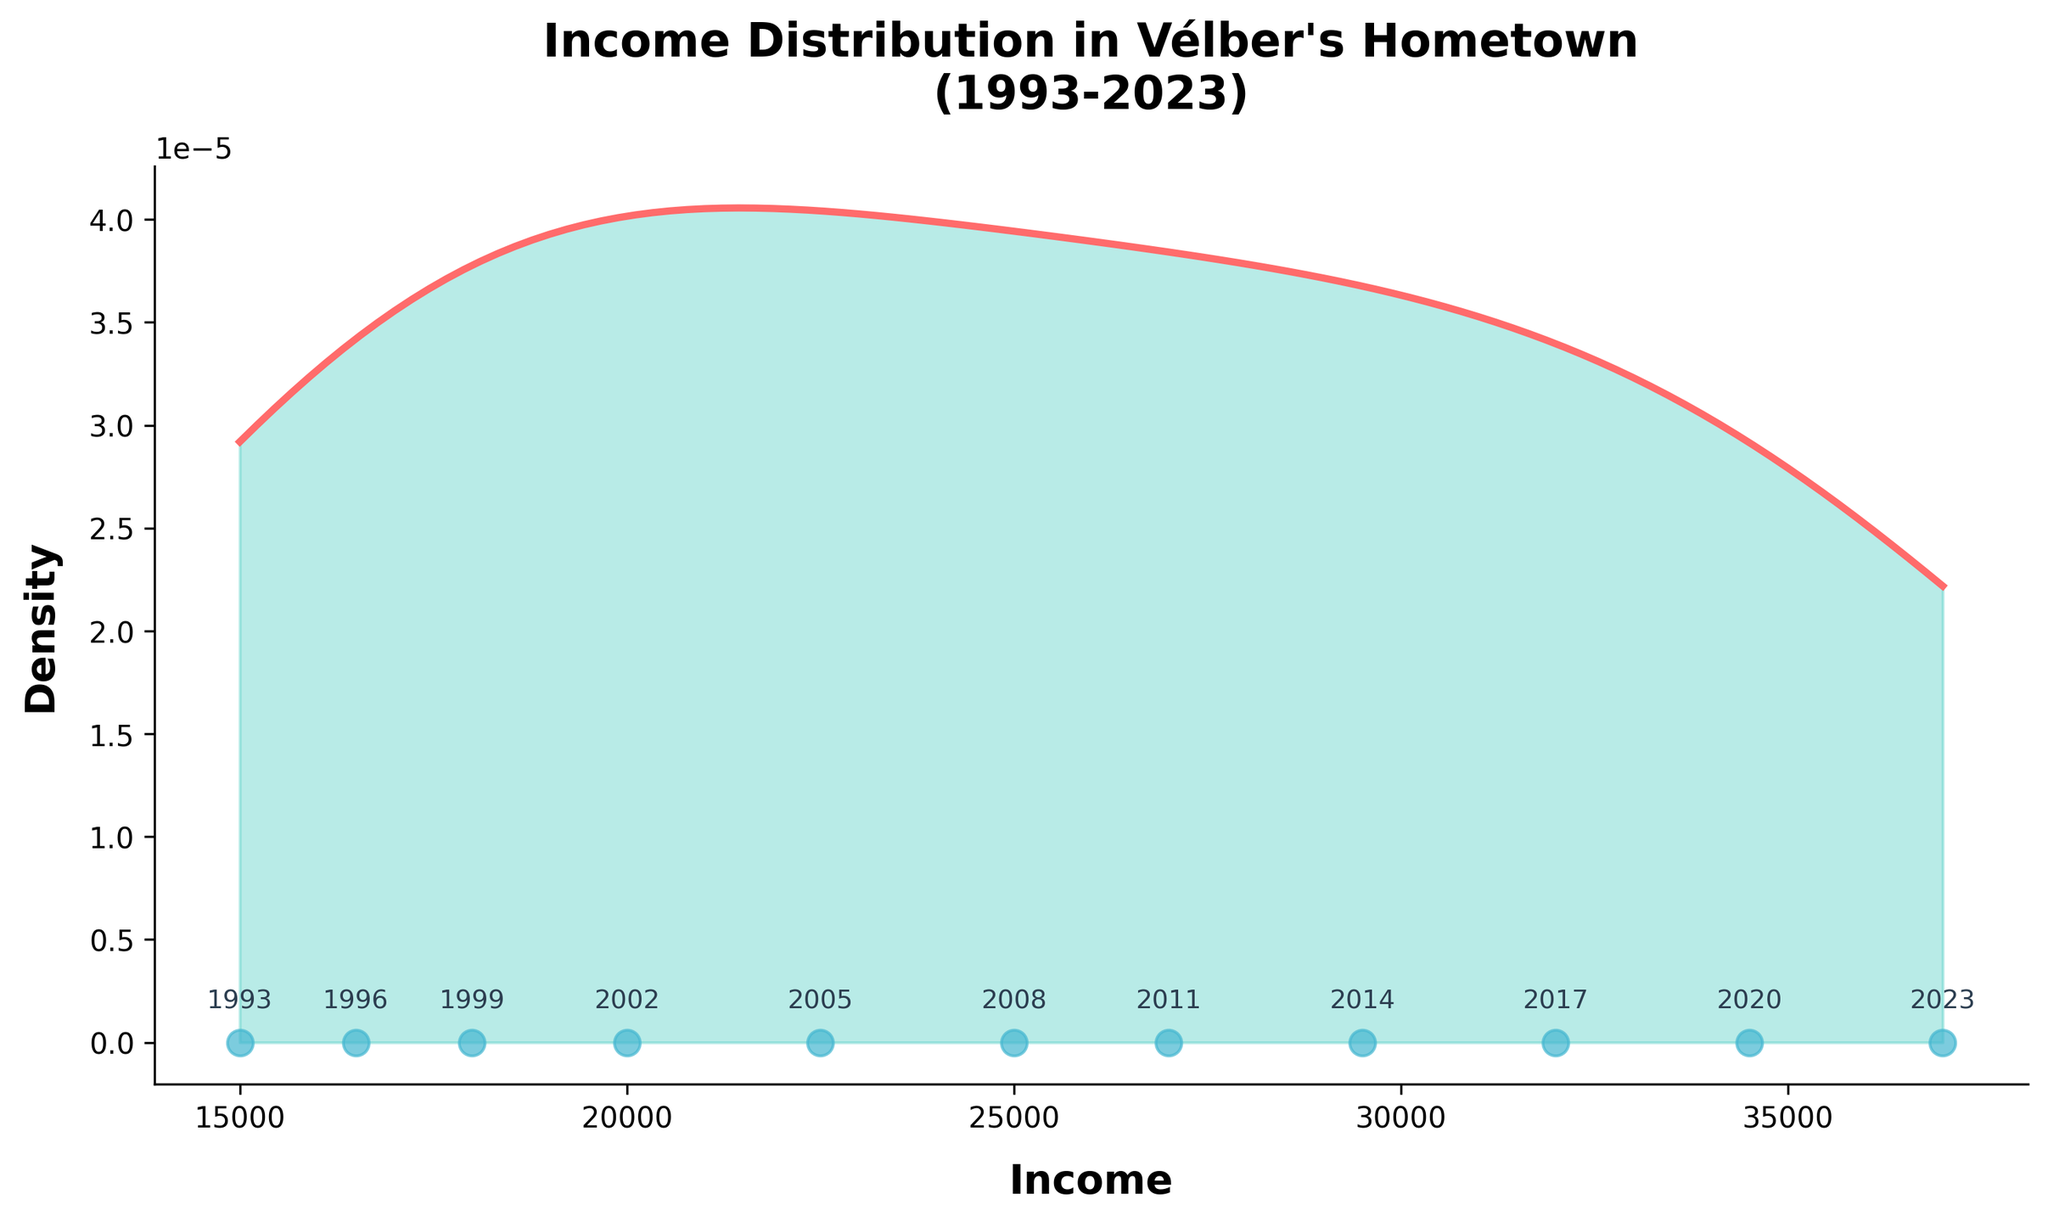what is the title of the plot? The title is located at the top of the figure, usually in a larger or bolder font. The title in this figure reads "Income Distribution in Vélber's Hometown (1993-2023)."
Answer: Income Distribution in Vélber's Hometown (1993-2023) how many data points are displayed in the figure? By counting the number of markers (dots) on the plot, we can determine how many data points there are. Each dot represents an income value for a year; there are 11 dots in the figure.
Answer: 11 what is the highest income value displayed? The highest income value can be identified by looking at the rightmost point on the horizontal axis, which is labeled. In this figure, the highest income value is 37000.
Answer: 37000 what are the color-coded areas below the curve representing? The areas below the curve are filled with a color to represent the density of income distribution. This added shading highlights where income values are more concentrated.
Answer: Density of income distribution which year has an income value closest to 20000? We look for the data point that is closest to the income value of 20000 on the horizontal axis and see which year it is labeled with. The point closest to 20000 is labeled 2002.
Answer: 2002 when was the income value just above 29000? We need to find the income value slightly above 29000 on the horizontal axis and read the corresponding year. Just above 29000 is the year labeled 2014.
Answer: 2014 how has the income distribution changed over time? Observing the scatter plot and the shape of the KDE curve, we can see that the income values have been increasing steadily from left (lower values) to the right (higher values) over the years. This implies a growth in income over time.
Answer: Income values have increased steadily over the years what period had the steepest growth in income? We observe the distances between consecutive data points on the horizontal axis to find the pairs with the largest gap. The steepest growth is between 2011 and 2014 where income jumped from 27000 to 29500.
Answer: 2011 to 2014 which decade shows the most significant change in income distribution density? By comparing the kernel density estimation (KDE) curves over different decades, we can see that the curve becomes higher and narrower in the later years, indicating a significant change. The most significant change appears to be from the 2010s onwards.
Answer: 2010s is the income distribution more skewed towards higher or lower income values? By examining the shape of the KDE curve, we see a longer tail on the left side, towards lower income values, meaning the distribution is right-skewed.
Answer: Higher income values 